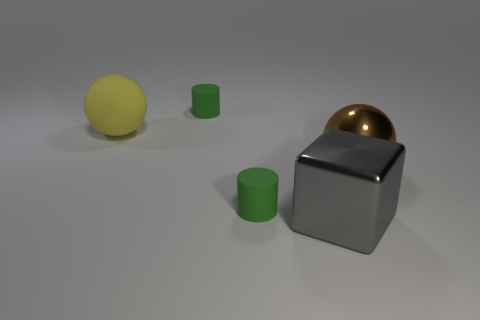There is another thing that is the same shape as the big yellow rubber thing; what is its color?
Provide a succinct answer. Brown. There is a large metal thing that is to the right of the big cube; does it have the same color as the large sphere that is left of the big gray shiny object?
Provide a short and direct response. No. What number of spheres are either big objects or blue objects?
Provide a succinct answer. 2. Are there an equal number of tiny green matte things that are left of the cube and tiny cylinders?
Ensure brevity in your answer.  Yes. The ball that is to the right of the metal object that is on the left side of the metallic thing that is right of the large metal block is made of what material?
Ensure brevity in your answer.  Metal. What number of things are either tiny green objects behind the gray cube or yellow rubber spheres?
Provide a succinct answer. 3. How many things are either big gray shiny cubes or big shiny things that are on the right side of the metal block?
Your answer should be compact. 2. How many gray shiny cubes are on the left side of the small green rubber thing behind the large ball right of the large yellow thing?
Keep it short and to the point. 0. What is the material of the gray cube that is the same size as the rubber ball?
Keep it short and to the point. Metal. Is there a blue cube that has the same size as the brown metallic object?
Make the answer very short. No. 